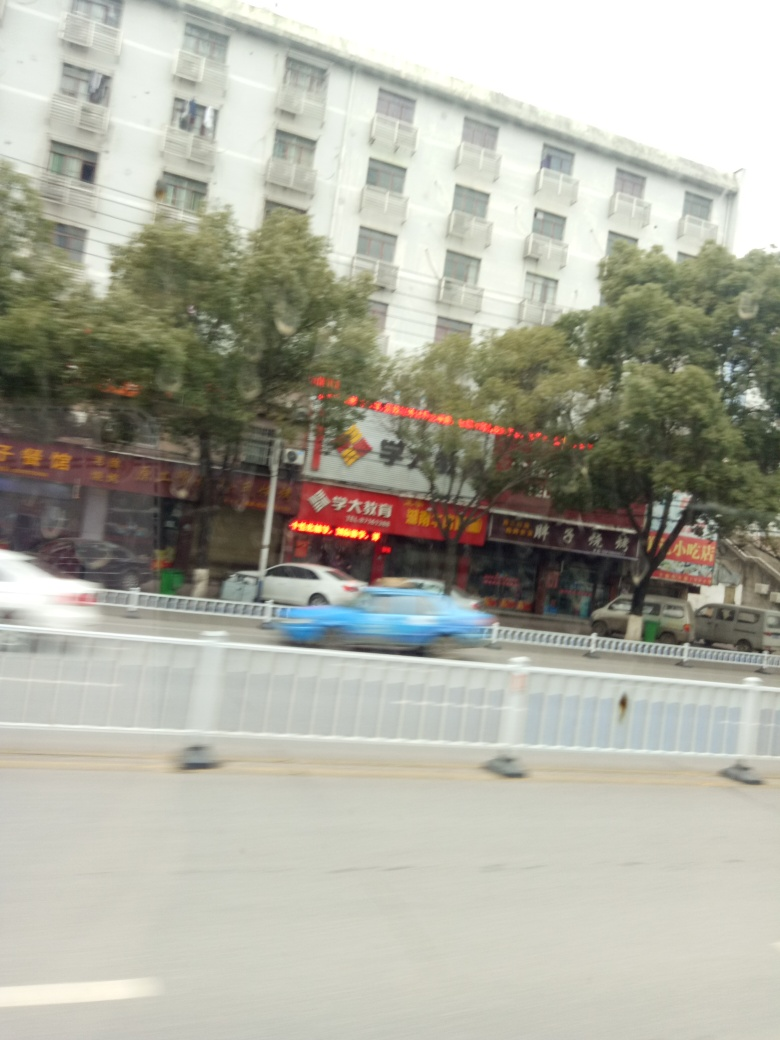How does the image composition affect its aesthetic quality? The composition of this image delivers an authentic representation of daily life in an urban environment. However, from an artistic standpoint, the tilt and motion blur introduce a sense of hasty, candid capture, rather than a studied, stable composition. It's more evocative of a snapshot than a carefully framed photograph, granting it a raw, immediate feel. 